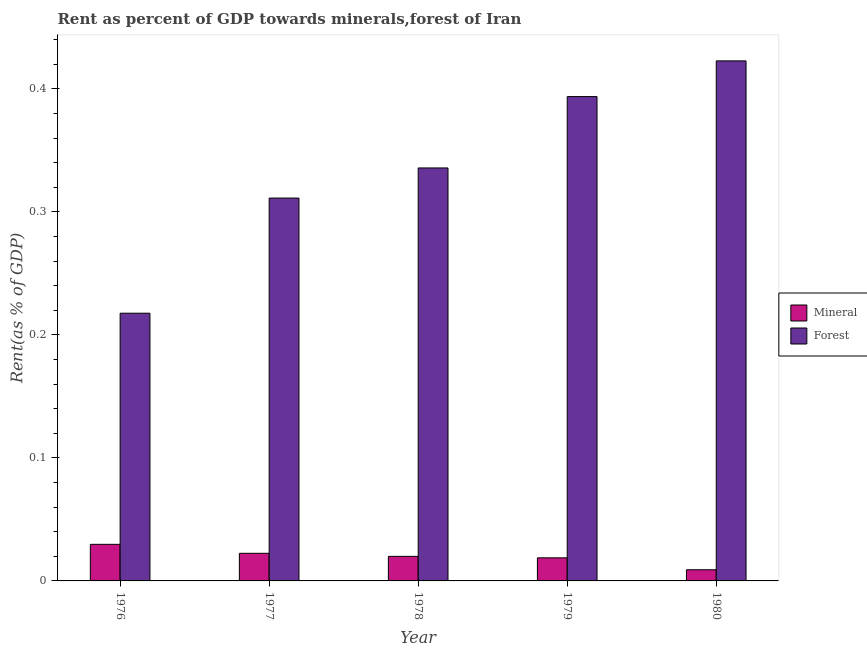How many groups of bars are there?
Your response must be concise. 5. Are the number of bars on each tick of the X-axis equal?
Your answer should be very brief. Yes. How many bars are there on the 1st tick from the left?
Make the answer very short. 2. What is the label of the 5th group of bars from the left?
Your answer should be very brief. 1980. In how many cases, is the number of bars for a given year not equal to the number of legend labels?
Give a very brief answer. 0. What is the mineral rent in 1976?
Give a very brief answer. 0.03. Across all years, what is the maximum mineral rent?
Offer a very short reply. 0.03. Across all years, what is the minimum mineral rent?
Your answer should be compact. 0.01. In which year was the forest rent maximum?
Ensure brevity in your answer.  1980. In which year was the forest rent minimum?
Provide a short and direct response. 1976. What is the total forest rent in the graph?
Your answer should be very brief. 1.68. What is the difference between the mineral rent in 1976 and that in 1980?
Offer a very short reply. 0.02. What is the difference between the mineral rent in 1978 and the forest rent in 1980?
Give a very brief answer. 0.01. What is the average forest rent per year?
Provide a succinct answer. 0.34. What is the ratio of the mineral rent in 1978 to that in 1980?
Your response must be concise. 2.2. What is the difference between the highest and the second highest forest rent?
Your response must be concise. 0.03. What is the difference between the highest and the lowest forest rent?
Provide a succinct answer. 0.21. What does the 2nd bar from the left in 1976 represents?
Offer a terse response. Forest. What does the 1st bar from the right in 1978 represents?
Give a very brief answer. Forest. How many bars are there?
Your answer should be compact. 10. Are all the bars in the graph horizontal?
Provide a short and direct response. No. How many years are there in the graph?
Provide a short and direct response. 5. Does the graph contain any zero values?
Offer a terse response. No. Where does the legend appear in the graph?
Offer a very short reply. Center right. How are the legend labels stacked?
Offer a very short reply. Vertical. What is the title of the graph?
Provide a succinct answer. Rent as percent of GDP towards minerals,forest of Iran. What is the label or title of the Y-axis?
Offer a very short reply. Rent(as % of GDP). What is the Rent(as % of GDP) in Mineral in 1976?
Ensure brevity in your answer.  0.03. What is the Rent(as % of GDP) of Forest in 1976?
Offer a very short reply. 0.22. What is the Rent(as % of GDP) of Mineral in 1977?
Ensure brevity in your answer.  0.02. What is the Rent(as % of GDP) of Forest in 1977?
Make the answer very short. 0.31. What is the Rent(as % of GDP) of Mineral in 1978?
Give a very brief answer. 0.02. What is the Rent(as % of GDP) of Forest in 1978?
Keep it short and to the point. 0.34. What is the Rent(as % of GDP) in Mineral in 1979?
Ensure brevity in your answer.  0.02. What is the Rent(as % of GDP) of Forest in 1979?
Give a very brief answer. 0.39. What is the Rent(as % of GDP) in Mineral in 1980?
Make the answer very short. 0.01. What is the Rent(as % of GDP) of Forest in 1980?
Keep it short and to the point. 0.42. Across all years, what is the maximum Rent(as % of GDP) of Mineral?
Offer a very short reply. 0.03. Across all years, what is the maximum Rent(as % of GDP) of Forest?
Provide a succinct answer. 0.42. Across all years, what is the minimum Rent(as % of GDP) of Mineral?
Give a very brief answer. 0.01. Across all years, what is the minimum Rent(as % of GDP) of Forest?
Offer a very short reply. 0.22. What is the total Rent(as % of GDP) of Forest in the graph?
Provide a succinct answer. 1.68. What is the difference between the Rent(as % of GDP) of Mineral in 1976 and that in 1977?
Keep it short and to the point. 0.01. What is the difference between the Rent(as % of GDP) of Forest in 1976 and that in 1977?
Your answer should be compact. -0.09. What is the difference between the Rent(as % of GDP) of Mineral in 1976 and that in 1978?
Give a very brief answer. 0.01. What is the difference between the Rent(as % of GDP) of Forest in 1976 and that in 1978?
Your answer should be compact. -0.12. What is the difference between the Rent(as % of GDP) of Mineral in 1976 and that in 1979?
Provide a succinct answer. 0.01. What is the difference between the Rent(as % of GDP) in Forest in 1976 and that in 1979?
Your answer should be compact. -0.18. What is the difference between the Rent(as % of GDP) in Mineral in 1976 and that in 1980?
Make the answer very short. 0.02. What is the difference between the Rent(as % of GDP) of Forest in 1976 and that in 1980?
Provide a short and direct response. -0.21. What is the difference between the Rent(as % of GDP) of Mineral in 1977 and that in 1978?
Your answer should be very brief. 0. What is the difference between the Rent(as % of GDP) in Forest in 1977 and that in 1978?
Make the answer very short. -0.02. What is the difference between the Rent(as % of GDP) in Mineral in 1977 and that in 1979?
Your answer should be compact. 0. What is the difference between the Rent(as % of GDP) of Forest in 1977 and that in 1979?
Ensure brevity in your answer.  -0.08. What is the difference between the Rent(as % of GDP) in Mineral in 1977 and that in 1980?
Keep it short and to the point. 0.01. What is the difference between the Rent(as % of GDP) in Forest in 1977 and that in 1980?
Ensure brevity in your answer.  -0.11. What is the difference between the Rent(as % of GDP) in Mineral in 1978 and that in 1979?
Offer a terse response. 0. What is the difference between the Rent(as % of GDP) in Forest in 1978 and that in 1979?
Make the answer very short. -0.06. What is the difference between the Rent(as % of GDP) in Mineral in 1978 and that in 1980?
Give a very brief answer. 0.01. What is the difference between the Rent(as % of GDP) in Forest in 1978 and that in 1980?
Make the answer very short. -0.09. What is the difference between the Rent(as % of GDP) in Mineral in 1979 and that in 1980?
Ensure brevity in your answer.  0.01. What is the difference between the Rent(as % of GDP) in Forest in 1979 and that in 1980?
Ensure brevity in your answer.  -0.03. What is the difference between the Rent(as % of GDP) in Mineral in 1976 and the Rent(as % of GDP) in Forest in 1977?
Your answer should be very brief. -0.28. What is the difference between the Rent(as % of GDP) of Mineral in 1976 and the Rent(as % of GDP) of Forest in 1978?
Keep it short and to the point. -0.31. What is the difference between the Rent(as % of GDP) in Mineral in 1976 and the Rent(as % of GDP) in Forest in 1979?
Offer a very short reply. -0.36. What is the difference between the Rent(as % of GDP) of Mineral in 1976 and the Rent(as % of GDP) of Forest in 1980?
Provide a succinct answer. -0.39. What is the difference between the Rent(as % of GDP) in Mineral in 1977 and the Rent(as % of GDP) in Forest in 1978?
Keep it short and to the point. -0.31. What is the difference between the Rent(as % of GDP) in Mineral in 1977 and the Rent(as % of GDP) in Forest in 1979?
Ensure brevity in your answer.  -0.37. What is the difference between the Rent(as % of GDP) in Mineral in 1977 and the Rent(as % of GDP) in Forest in 1980?
Ensure brevity in your answer.  -0.4. What is the difference between the Rent(as % of GDP) of Mineral in 1978 and the Rent(as % of GDP) of Forest in 1979?
Provide a short and direct response. -0.37. What is the difference between the Rent(as % of GDP) in Mineral in 1978 and the Rent(as % of GDP) in Forest in 1980?
Offer a terse response. -0.4. What is the difference between the Rent(as % of GDP) of Mineral in 1979 and the Rent(as % of GDP) of Forest in 1980?
Keep it short and to the point. -0.4. What is the average Rent(as % of GDP) of Mineral per year?
Offer a very short reply. 0.02. What is the average Rent(as % of GDP) in Forest per year?
Give a very brief answer. 0.34. In the year 1976, what is the difference between the Rent(as % of GDP) in Mineral and Rent(as % of GDP) in Forest?
Provide a short and direct response. -0.19. In the year 1977, what is the difference between the Rent(as % of GDP) of Mineral and Rent(as % of GDP) of Forest?
Offer a terse response. -0.29. In the year 1978, what is the difference between the Rent(as % of GDP) of Mineral and Rent(as % of GDP) of Forest?
Offer a very short reply. -0.32. In the year 1979, what is the difference between the Rent(as % of GDP) of Mineral and Rent(as % of GDP) of Forest?
Your answer should be very brief. -0.38. In the year 1980, what is the difference between the Rent(as % of GDP) of Mineral and Rent(as % of GDP) of Forest?
Your answer should be compact. -0.41. What is the ratio of the Rent(as % of GDP) of Mineral in 1976 to that in 1977?
Give a very brief answer. 1.32. What is the ratio of the Rent(as % of GDP) in Forest in 1976 to that in 1977?
Make the answer very short. 0.7. What is the ratio of the Rent(as % of GDP) in Mineral in 1976 to that in 1978?
Your response must be concise. 1.49. What is the ratio of the Rent(as % of GDP) of Forest in 1976 to that in 1978?
Offer a terse response. 0.65. What is the ratio of the Rent(as % of GDP) in Mineral in 1976 to that in 1979?
Keep it short and to the point. 1.58. What is the ratio of the Rent(as % of GDP) in Forest in 1976 to that in 1979?
Give a very brief answer. 0.55. What is the ratio of the Rent(as % of GDP) of Mineral in 1976 to that in 1980?
Give a very brief answer. 3.28. What is the ratio of the Rent(as % of GDP) in Forest in 1976 to that in 1980?
Keep it short and to the point. 0.51. What is the ratio of the Rent(as % of GDP) in Mineral in 1977 to that in 1978?
Make the answer very short. 1.12. What is the ratio of the Rent(as % of GDP) of Forest in 1977 to that in 1978?
Make the answer very short. 0.93. What is the ratio of the Rent(as % of GDP) in Mineral in 1977 to that in 1979?
Provide a short and direct response. 1.2. What is the ratio of the Rent(as % of GDP) of Forest in 1977 to that in 1979?
Make the answer very short. 0.79. What is the ratio of the Rent(as % of GDP) of Mineral in 1977 to that in 1980?
Your answer should be very brief. 2.47. What is the ratio of the Rent(as % of GDP) in Forest in 1977 to that in 1980?
Your answer should be compact. 0.74. What is the ratio of the Rent(as % of GDP) in Mineral in 1978 to that in 1979?
Give a very brief answer. 1.06. What is the ratio of the Rent(as % of GDP) in Forest in 1978 to that in 1979?
Your response must be concise. 0.85. What is the ratio of the Rent(as % of GDP) of Mineral in 1978 to that in 1980?
Keep it short and to the point. 2.2. What is the ratio of the Rent(as % of GDP) in Forest in 1978 to that in 1980?
Your answer should be compact. 0.79. What is the ratio of the Rent(as % of GDP) in Mineral in 1979 to that in 1980?
Ensure brevity in your answer.  2.07. What is the ratio of the Rent(as % of GDP) in Forest in 1979 to that in 1980?
Make the answer very short. 0.93. What is the difference between the highest and the second highest Rent(as % of GDP) in Mineral?
Offer a terse response. 0.01. What is the difference between the highest and the second highest Rent(as % of GDP) of Forest?
Your answer should be very brief. 0.03. What is the difference between the highest and the lowest Rent(as % of GDP) of Mineral?
Ensure brevity in your answer.  0.02. What is the difference between the highest and the lowest Rent(as % of GDP) of Forest?
Keep it short and to the point. 0.21. 